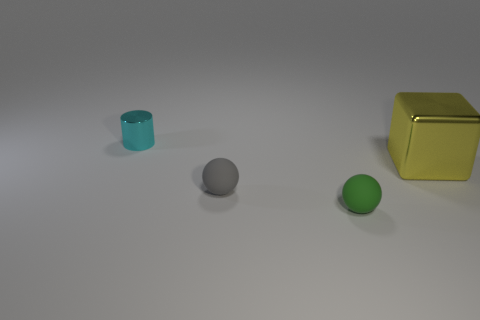Are there any other things that are the same size as the yellow block?
Offer a very short reply. No. What number of rubber objects are cyan cylinders or spheres?
Keep it short and to the point. 2. Is the number of green rubber spheres behind the gray matte thing less than the number of green objects right of the green matte ball?
Your response must be concise. No. How many objects are either tiny green spheres or tiny things in front of the tiny cylinder?
Provide a short and direct response. 2. There is a cyan thing that is the same size as the green matte ball; what is its material?
Ensure brevity in your answer.  Metal. Does the green sphere have the same material as the gray sphere?
Offer a terse response. Yes. There is a thing that is both right of the small gray rubber thing and in front of the big yellow thing; what is its color?
Offer a terse response. Green. Do the thing behind the yellow cube and the metallic cube have the same color?
Offer a terse response. No. What is the shape of the green matte object that is the same size as the gray object?
Offer a terse response. Sphere. How many other things are there of the same color as the small cylinder?
Your response must be concise. 0. 